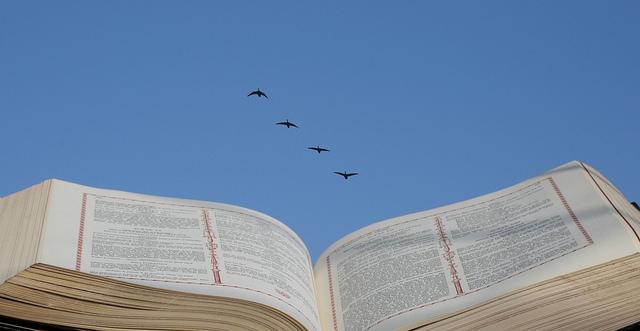Are these 4 planes in the sky?
Keep it brief. No. What kind of book is this?
Give a very brief answer. Bible. How many birds are in the sky?
Be succinct. 4. 